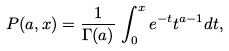Convert formula to latex. <formula><loc_0><loc_0><loc_500><loc_500>P ( a , x ) = \frac { 1 } { \Gamma ( a ) } \, \int _ { 0 } ^ { x } e ^ { - t } t ^ { a - 1 } d t ,</formula> 